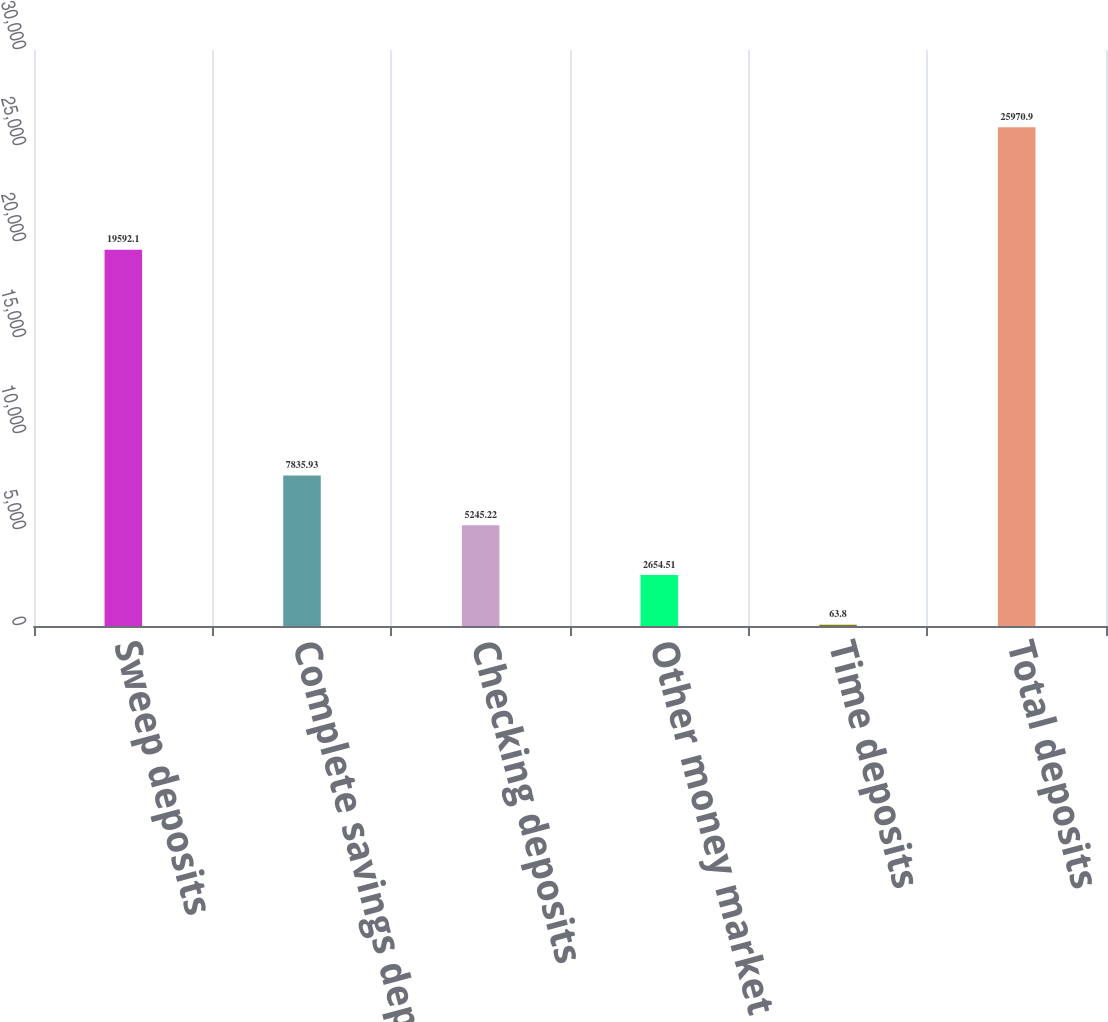Convert chart to OTSL. <chart><loc_0><loc_0><loc_500><loc_500><bar_chart><fcel>Sweep deposits<fcel>Complete savings deposits<fcel>Checking deposits<fcel>Other money market and savings<fcel>Time deposits<fcel>Total deposits<nl><fcel>19592.1<fcel>7835.93<fcel>5245.22<fcel>2654.51<fcel>63.8<fcel>25970.9<nl></chart> 